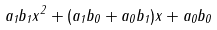<formula> <loc_0><loc_0><loc_500><loc_500>a _ { 1 } b _ { 1 } x ^ { 2 } + ( a _ { 1 } b _ { 0 } + a _ { 0 } b _ { 1 } ) x + a _ { 0 } b _ { 0 }</formula> 